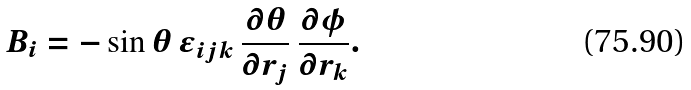Convert formula to latex. <formula><loc_0><loc_0><loc_500><loc_500>B _ { i } = - \sin \theta \, \epsilon _ { i j k } \, \frac { \partial \theta } { \partial r _ { j } } \, \frac { \partial \phi } { \partial r _ { k } } .</formula> 